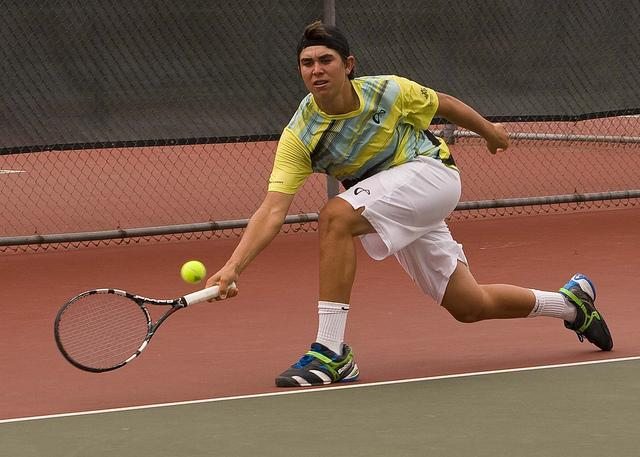What shot is he using to hit the ball?

Choices:
A) overhead
B) volley
C) backhand
D) forehand forehand 